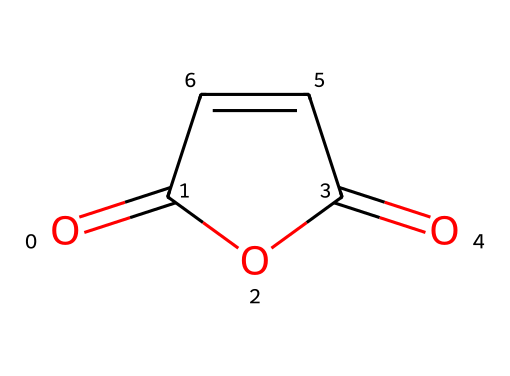What is the molecular formula of maleic anhydride? By interpreting the SMILES representation, we can deduce that the molecule contains four carbon atoms, two oxygen atoms, and four hydrogen atoms, resulting in the molecular formula C4H2O3.
Answer: C4H2O3 How many rings are present in this structure? The SMILES indicates a cyclic structure with an anhydride, and upon evaluating the structure, we can identify one ring (indicated by 'C1' and 'C1').
Answer: 1 What type of functional groups are present in maleic anhydride? The structure shows carbonyl (C=O) and anhydride functionalities, which are characteristic of acid anhydrides derived from dicarboxylic acids.
Answer: anhydride What is the total number of double bonds in the structure? In examining the structure, we observe two double bonds: one in the carbonyl group and another in the carbon-carbon double bond (C=C).
Answer: 2 Which element is present in the highest quantity? Analyzing the molecular structure reveals four carbon atoms (C), more than any other element present (hydrogen or oxygen).
Answer: carbon What is the reason maleic anhydride is used in copolymers? Maleic anhydride is reactive due to the presence of the anhydride group, which facilitates crosslinking in polymers, enhancing strength and durability.
Answer: reactivity 